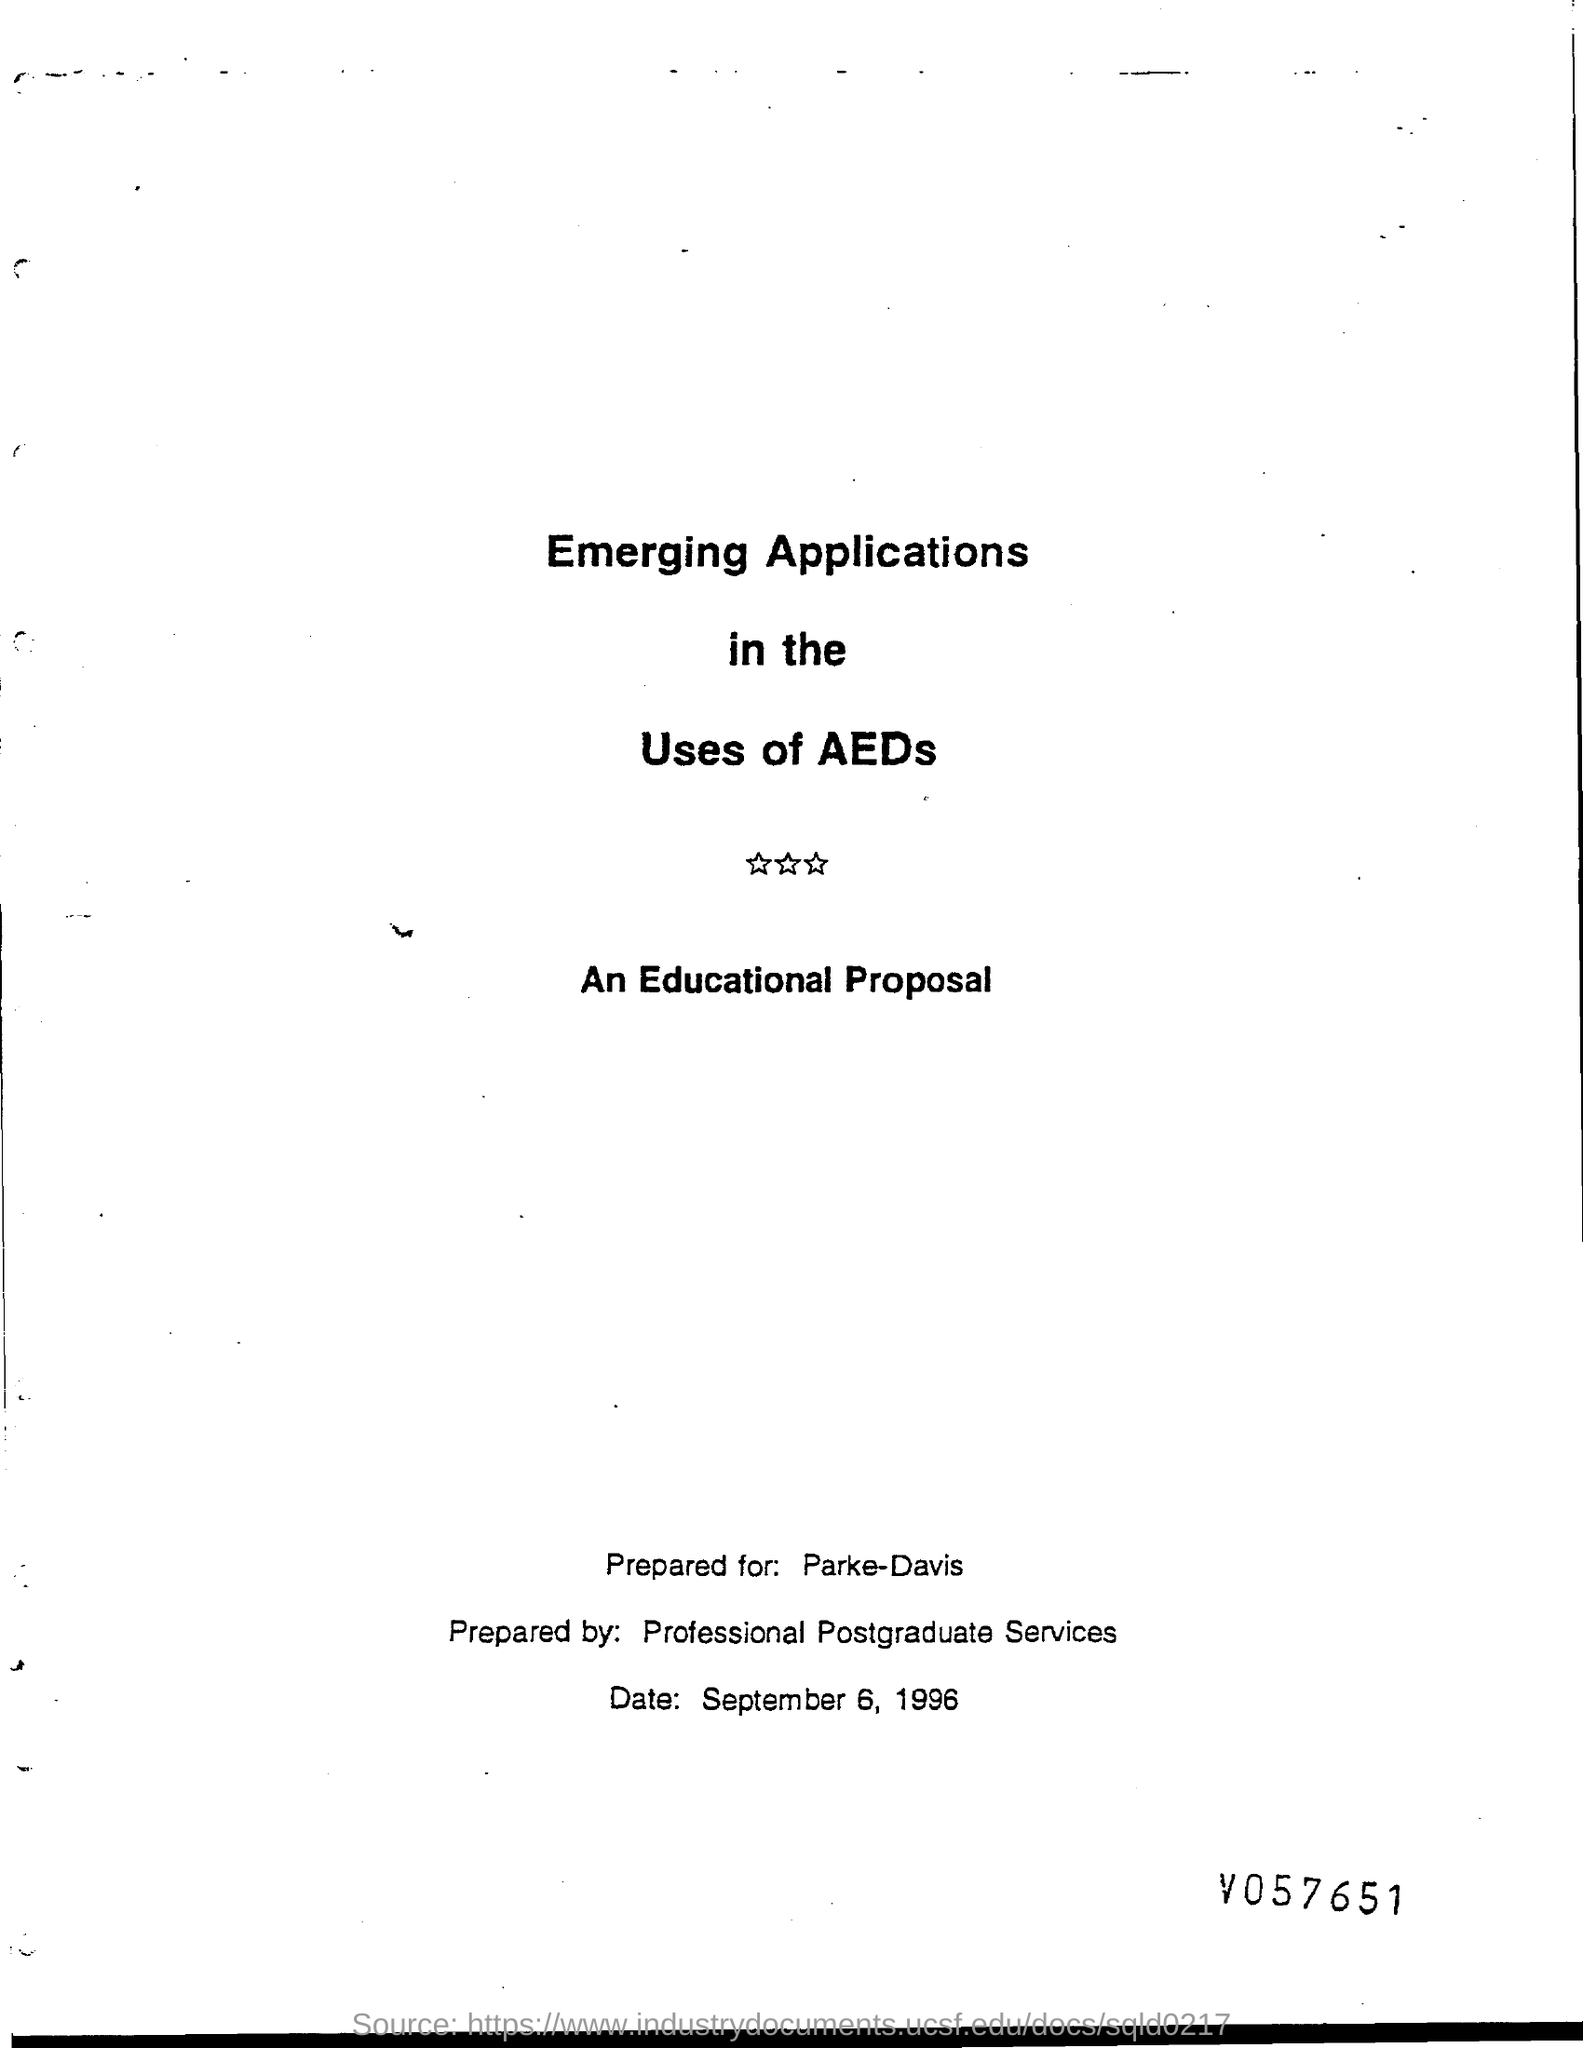What is date at bottom of the page?
Ensure brevity in your answer.  September 6, 1996. 